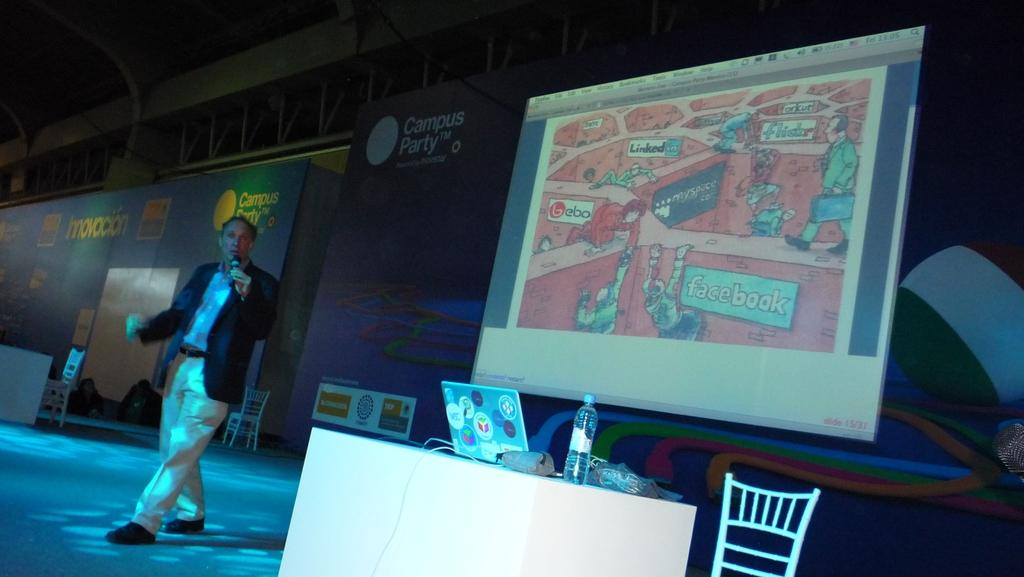What is the person in the image doing? The person is holding a microphone. What type of furniture is present in the image? There are tables and chairs in the image. What can be seen in the background of the image? There are screens visible in the background. What type of ball is being used to print on the screens in the image? There is no ball or printing activity present in the image; the person is holding a microphone, and there are screens visible in the background. 